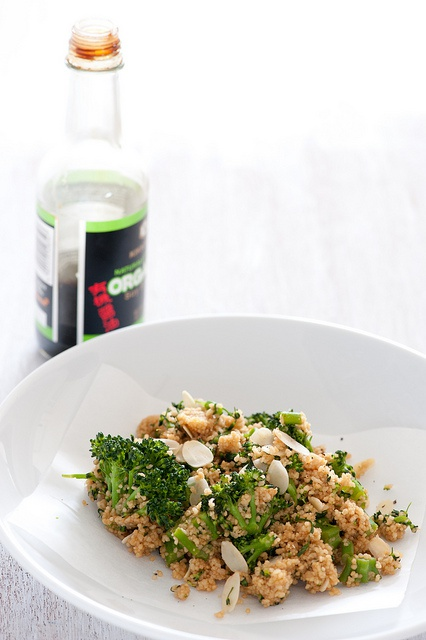Describe the objects in this image and their specific colors. I can see bowl in white, lightgray, olive, and black tones, bottle in white, black, gray, and darkgray tones, broccoli in white, black, darkgreen, and olive tones, broccoli in white, black, darkgreen, and olive tones, and broccoli in white, olive, black, darkgreen, and tan tones in this image. 